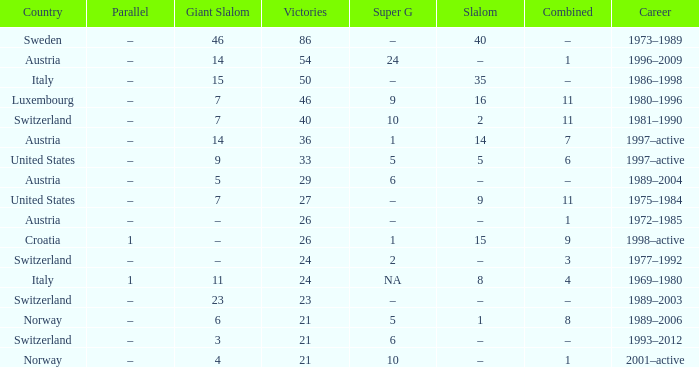What Country has a Career of 1989–2004? Austria. 